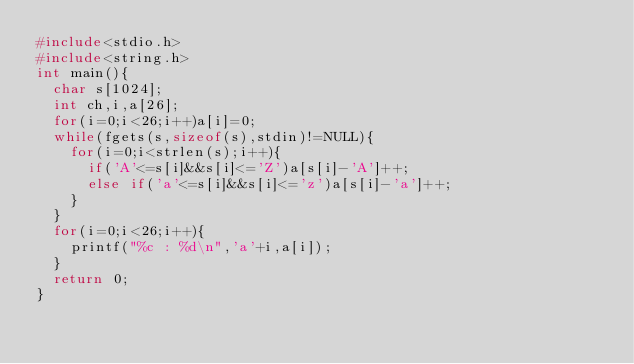<code> <loc_0><loc_0><loc_500><loc_500><_C_>#include<stdio.h>
#include<string.h>
int main(){
	char s[1024];
	int ch,i,a[26];
	for(i=0;i<26;i++)a[i]=0;
	while(fgets(s,sizeof(s),stdin)!=NULL){
		for(i=0;i<strlen(s);i++){
			if('A'<=s[i]&&s[i]<='Z')a[s[i]-'A']++;
			else if('a'<=s[i]&&s[i]<='z')a[s[i]-'a']++;
		}
	}
	for(i=0;i<26;i++){
		printf("%c : %d\n",'a'+i,a[i]);
	}
	return 0;
}
	</code> 